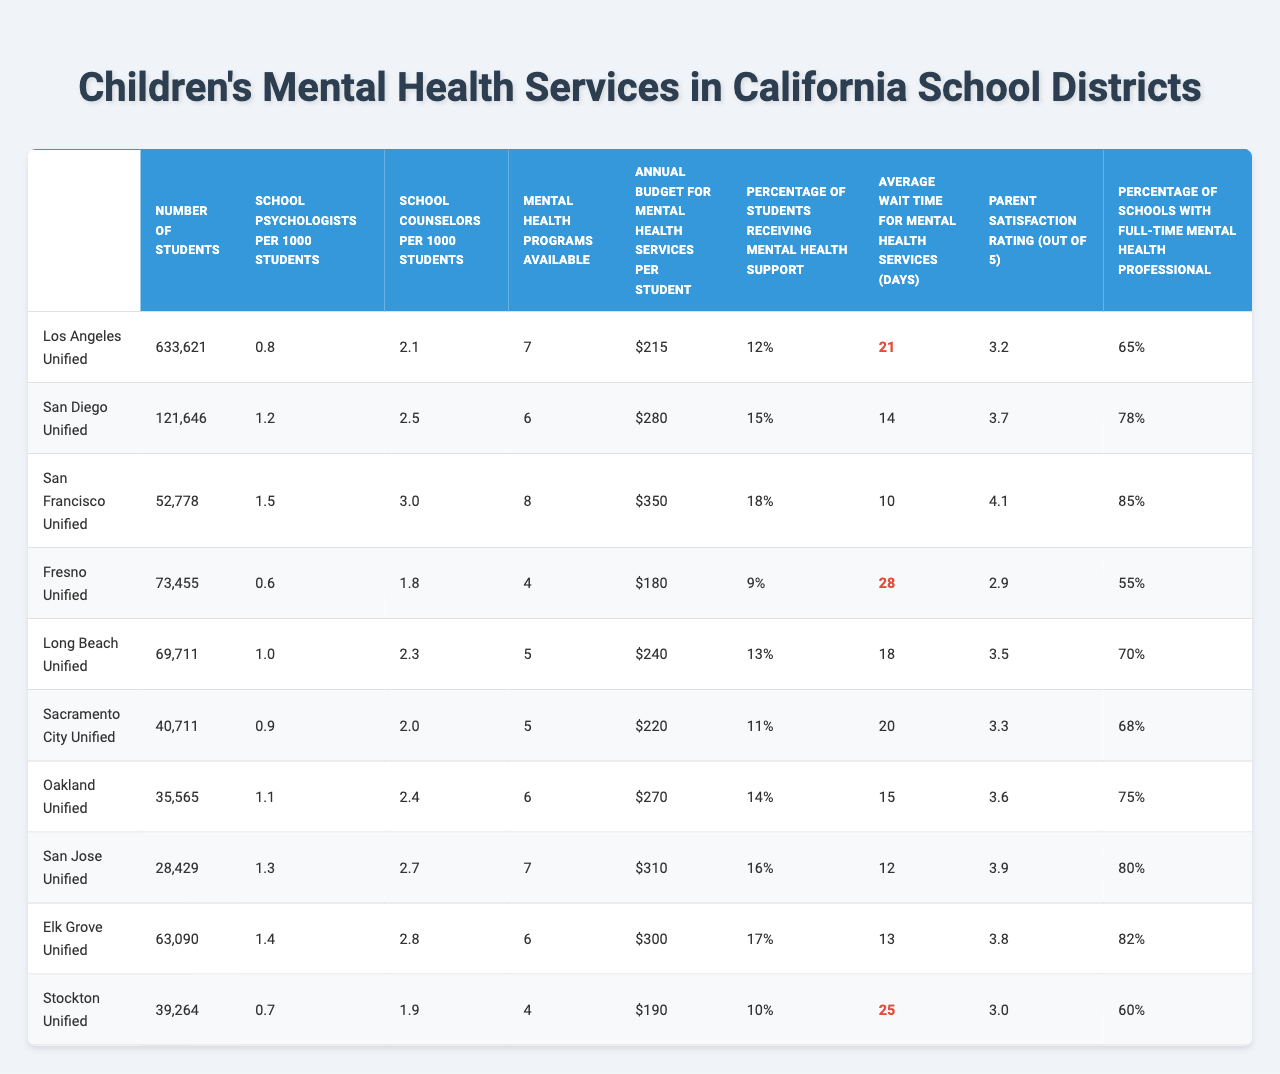What is the school district with the highest number of students? The table lists the number of students in each district, and by comparing these values, it is clear that Los Angeles Unified has the highest number of students at 633,621.
Answer: Los Angeles Unified Which school district has the lowest percentage of students receiving mental health support? By examining the percentages in the 'Percentage of Students Receiving Mental Health Support' column, the lowest value is 9% in Fresno Unified.
Answer: Fresno Unified What is the average annual budget for mental health services per student across all districts? To find the average, sum the budgets from all districts (215 + 280 + 350 + 180 + 240 + 220 + 270 + 310 + 300 + 190 = 2,335) and divide by the number of districts (10): 2,335 / 10 = 233.5.
Answer: 233.5 Do all school districts provide mental health programs? By checking the 'Mental Health Programs Available' column, it is evident that all school districts provide at least 4 programs, so yes, they all provide programs.
Answer: Yes How many more school counselors per 1000 students does San Francisco Unified have compared to Fresno Unified? The value for San Francisco Unified is 3.0 and for Fresno Unified it is 1.8. The difference is 3.0 - 1.8 = 1.2.
Answer: 1.2 What is the average wait time for mental health services in Oakland Unified and San Diego Unified? Oakland Unified has an average wait time of 15 days, while San Diego Unified has 14 days. The average wait time is (15 + 14) / 2 = 14.5 days.
Answer: 14.5 days Which school district reports the highest parent satisfaction rating? By examining the 'Parent Satisfaction Rating out of 5' column, San Francisco Unified has the highest rating of 4.1.
Answer: San Francisco Unified Is there a correlation between the number of school psychologists per 1000 students and the percentage of students receiving mental health support? By observing the values, districts with more psychologists generally have a higher percentage of support. For example, San Francisco has 1.5 psychologists and 18% support, while Fresno with 0.6 psychologists, has 9% support. Thus, there appears to be a positive correlation.
Answer: Yes What is the mental health support rating difference between the district with the highest percentage and the one with the lowest? The highest percentage is 18% from San Francisco Unified and the lowest is 9% from Fresno Unified, creating a difference of 18 - 9 = 9%.
Answer: 9% Which district has the least percentage of schools with a full-time mental health professional? By reviewing the 'Percentage of Schools with Full-Time Mental Health Professional' column, Fresno Unified is at the lowest with 55%.
Answer: Fresno Unified 